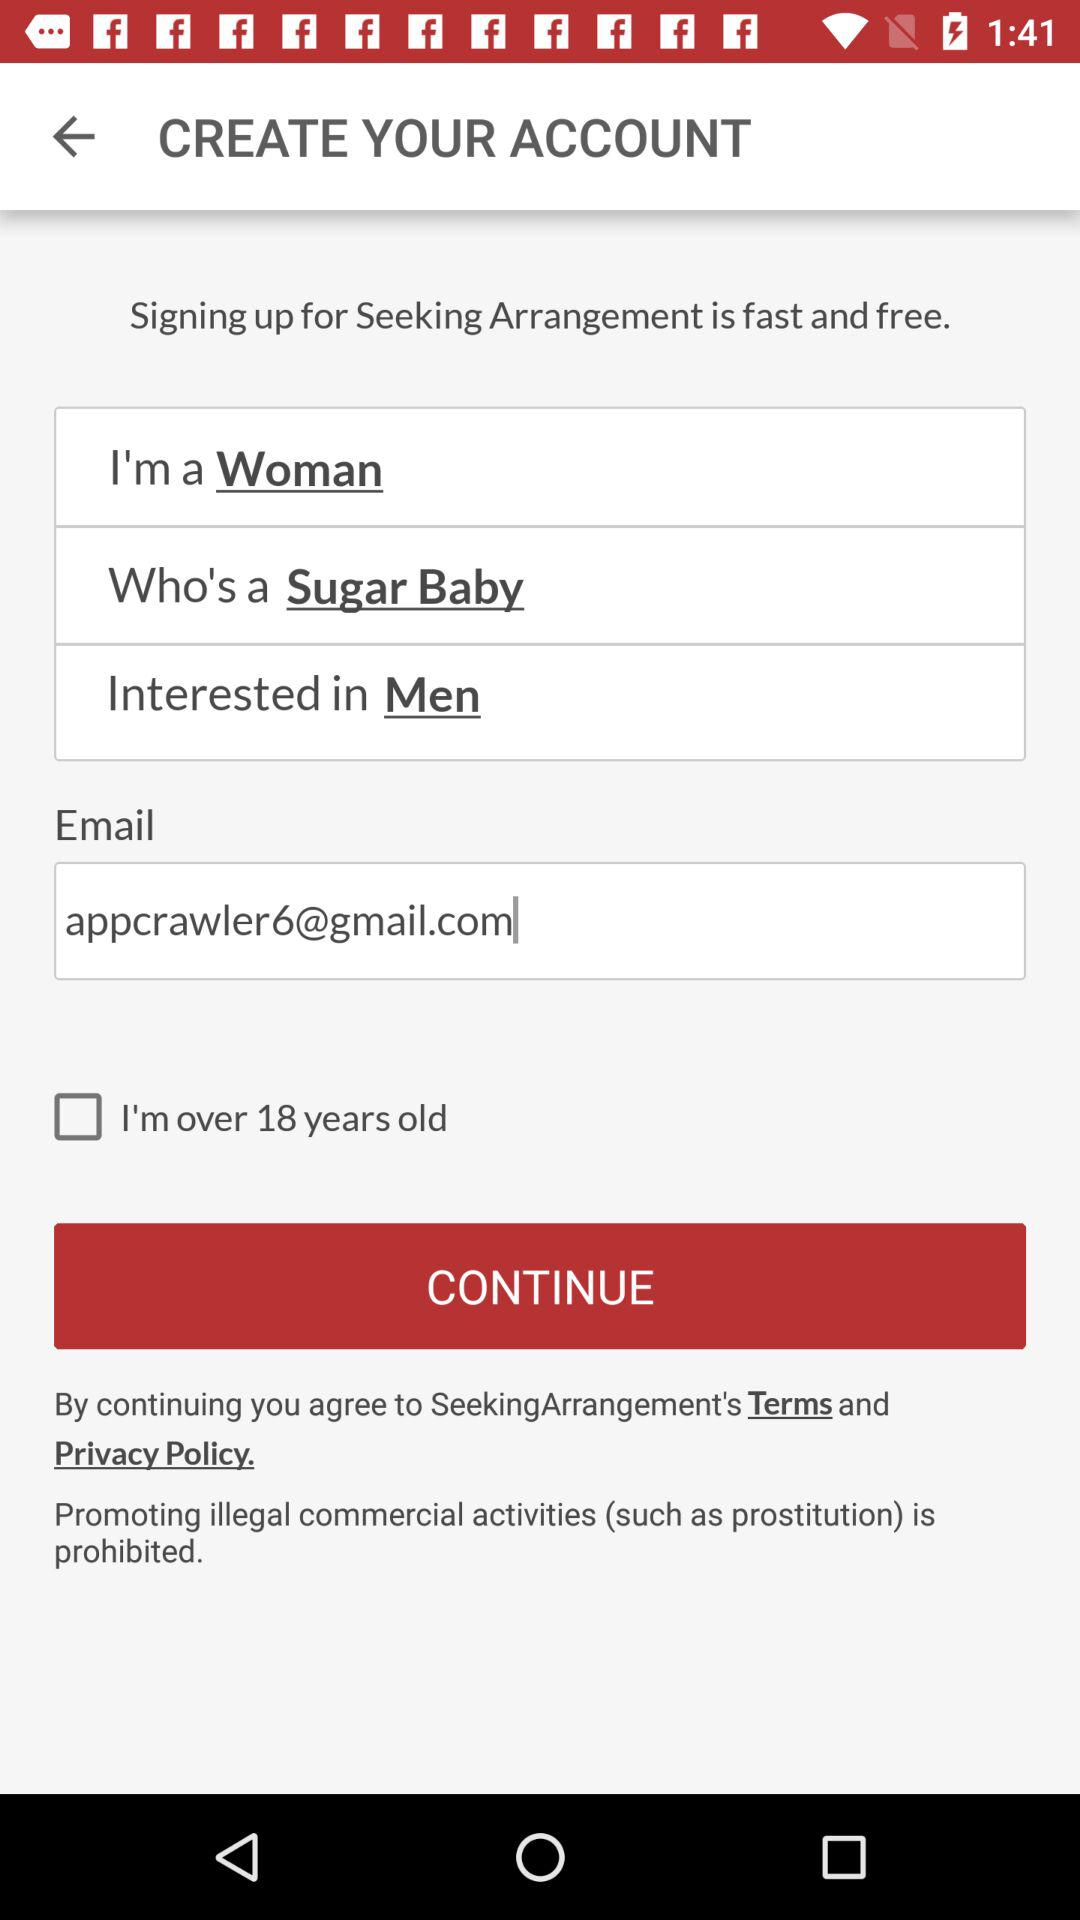Which category is the user interested in? The user is interested in men. 